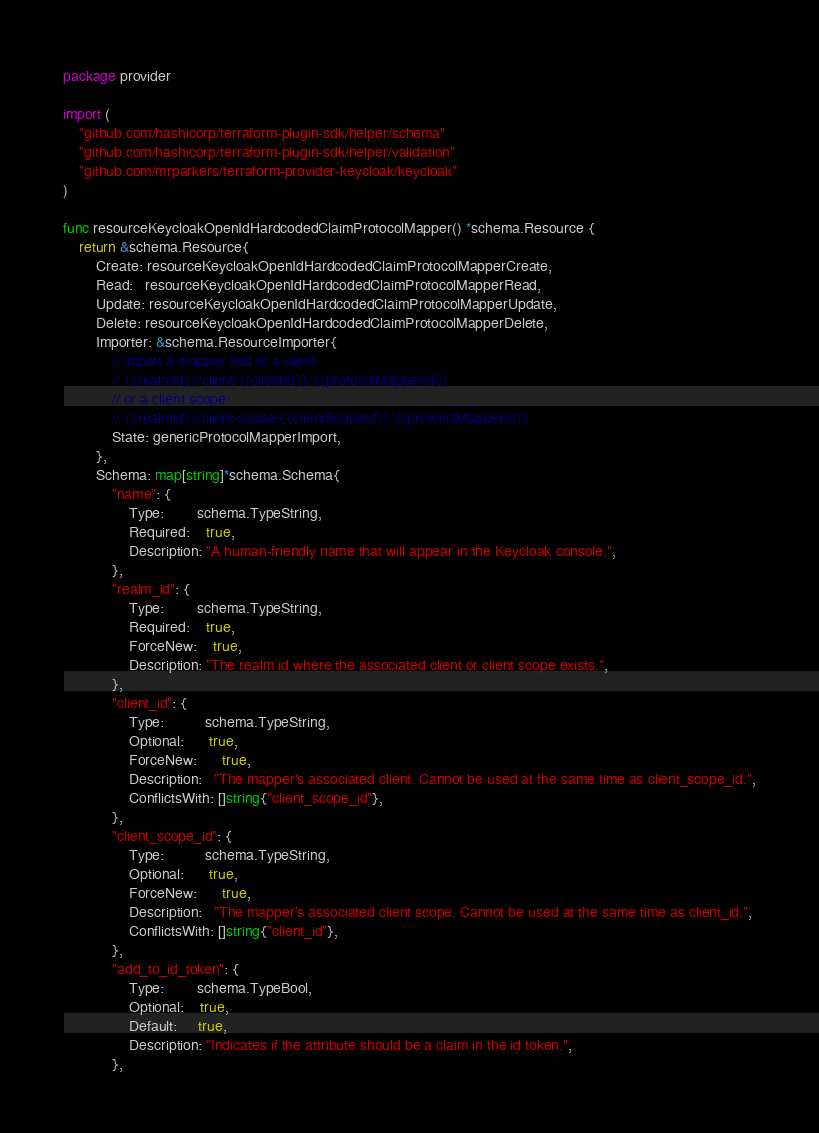Convert code to text. <code><loc_0><loc_0><loc_500><loc_500><_Go_>package provider

import (
	"github.com/hashicorp/terraform-plugin-sdk/helper/schema"
	"github.com/hashicorp/terraform-plugin-sdk/helper/validation"
	"github.com/mrparkers/terraform-provider-keycloak/keycloak"
)

func resourceKeycloakOpenIdHardcodedClaimProtocolMapper() *schema.Resource {
	return &schema.Resource{
		Create: resourceKeycloakOpenIdHardcodedClaimProtocolMapperCreate,
		Read:   resourceKeycloakOpenIdHardcodedClaimProtocolMapperRead,
		Update: resourceKeycloakOpenIdHardcodedClaimProtocolMapperUpdate,
		Delete: resourceKeycloakOpenIdHardcodedClaimProtocolMapperDelete,
		Importer: &schema.ResourceImporter{
			// import a mapper tied to a client:
			// {{realmId}}/client/{{clientId}}/{{protocolMapperId}}
			// or a client scope:
			// {{realmId}}/client-scope/{{clientScopeId}}/{{protocolMapperId}}
			State: genericProtocolMapperImport,
		},
		Schema: map[string]*schema.Schema{
			"name": {
				Type:        schema.TypeString,
				Required:    true,
				Description: "A human-friendly name that will appear in the Keycloak console.",
			},
			"realm_id": {
				Type:        schema.TypeString,
				Required:    true,
				ForceNew:    true,
				Description: "The realm id where the associated client or client scope exists.",
			},
			"client_id": {
				Type:          schema.TypeString,
				Optional:      true,
				ForceNew:      true,
				Description:   "The mapper's associated client. Cannot be used at the same time as client_scope_id.",
				ConflictsWith: []string{"client_scope_id"},
			},
			"client_scope_id": {
				Type:          schema.TypeString,
				Optional:      true,
				ForceNew:      true,
				Description:   "The mapper's associated client scope. Cannot be used at the same time as client_id.",
				ConflictsWith: []string{"client_id"},
			},
			"add_to_id_token": {
				Type:        schema.TypeBool,
				Optional:    true,
				Default:     true,
				Description: "Indicates if the attribute should be a claim in the id token.",
			},</code> 